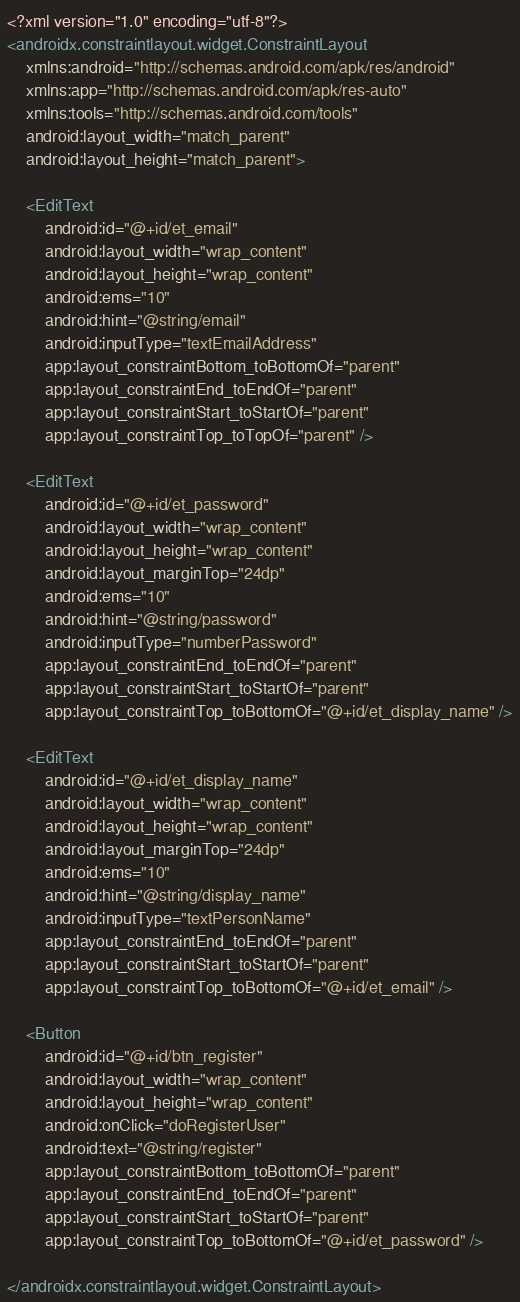Convert code to text. <code><loc_0><loc_0><loc_500><loc_500><_XML_><?xml version="1.0" encoding="utf-8"?>
<androidx.constraintlayout.widget.ConstraintLayout
    xmlns:android="http://schemas.android.com/apk/res/android"
    xmlns:app="http://schemas.android.com/apk/res-auto"
    xmlns:tools="http://schemas.android.com/tools"
    android:layout_width="match_parent"
    android:layout_height="match_parent">

    <EditText
        android:id="@+id/et_email"
        android:layout_width="wrap_content"
        android:layout_height="wrap_content"
        android:ems="10"
        android:hint="@string/email"
        android:inputType="textEmailAddress"
        app:layout_constraintBottom_toBottomOf="parent"
        app:layout_constraintEnd_toEndOf="parent"
        app:layout_constraintStart_toStartOf="parent"
        app:layout_constraintTop_toTopOf="parent" />

    <EditText
        android:id="@+id/et_password"
        android:layout_width="wrap_content"
        android:layout_height="wrap_content"
        android:layout_marginTop="24dp"
        android:ems="10"
        android:hint="@string/password"
        android:inputType="numberPassword"
        app:layout_constraintEnd_toEndOf="parent"
        app:layout_constraintStart_toStartOf="parent"
        app:layout_constraintTop_toBottomOf="@+id/et_display_name" />

    <EditText
        android:id="@+id/et_display_name"
        android:layout_width="wrap_content"
        android:layout_height="wrap_content"
        android:layout_marginTop="24dp"
        android:ems="10"
        android:hint="@string/display_name"
        android:inputType="textPersonName"
        app:layout_constraintEnd_toEndOf="parent"
        app:layout_constraintStart_toStartOf="parent"
        app:layout_constraintTop_toBottomOf="@+id/et_email" />

    <Button
        android:id="@+id/btn_register"
        android:layout_width="wrap_content"
        android:layout_height="wrap_content"
        android:onClick="doRegisterUser"
        android:text="@string/register"
        app:layout_constraintBottom_toBottomOf="parent"
        app:layout_constraintEnd_toEndOf="parent"
        app:layout_constraintStart_toStartOf="parent"
        app:layout_constraintTop_toBottomOf="@+id/et_password" />

</androidx.constraintlayout.widget.ConstraintLayout></code> 